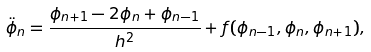<formula> <loc_0><loc_0><loc_500><loc_500>\ddot { \phi } _ { n } = \frac { \phi _ { n + 1 } - 2 \phi _ { n } + \phi _ { n - 1 } } { h ^ { 2 } } + f ( \phi _ { n - 1 } , \phi _ { n } , \phi _ { n + 1 } ) ,</formula> 